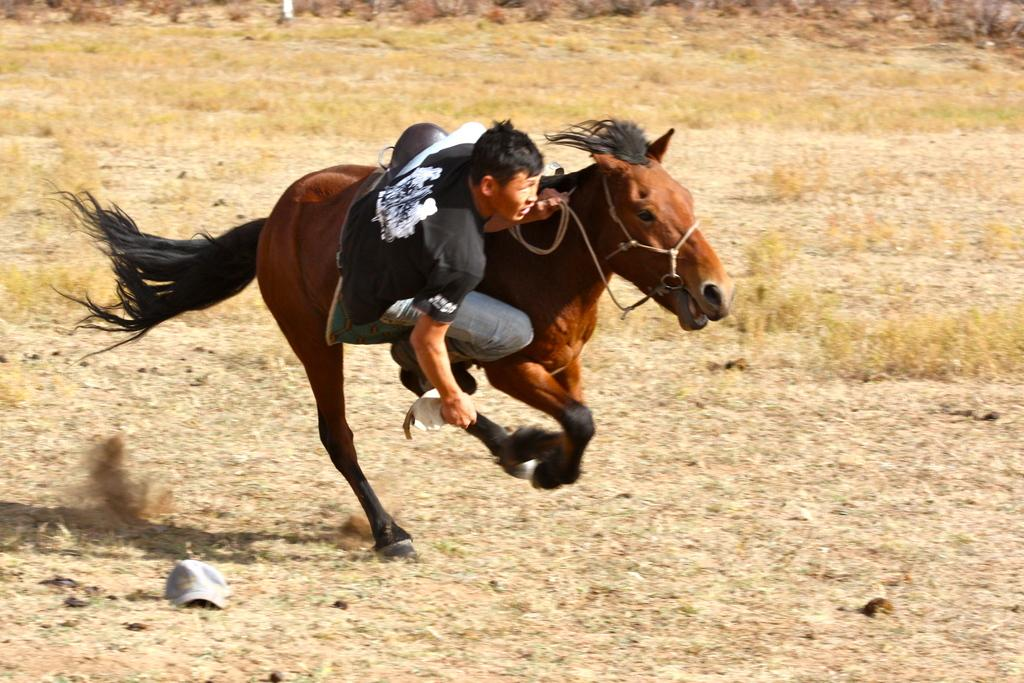What animal is present in the image? There is a horse in the image. What is the horse doing in the image? The horse is running. Is there anyone riding the horse? Yes, there is a person on the horse. What type of terrain can be seen in the image? There is ground visible in the image, and there is grass present. What type of necklace is the woman wearing in the image? There is no woman present in the image, so it is not possible to determine if she is wearing a necklace. 